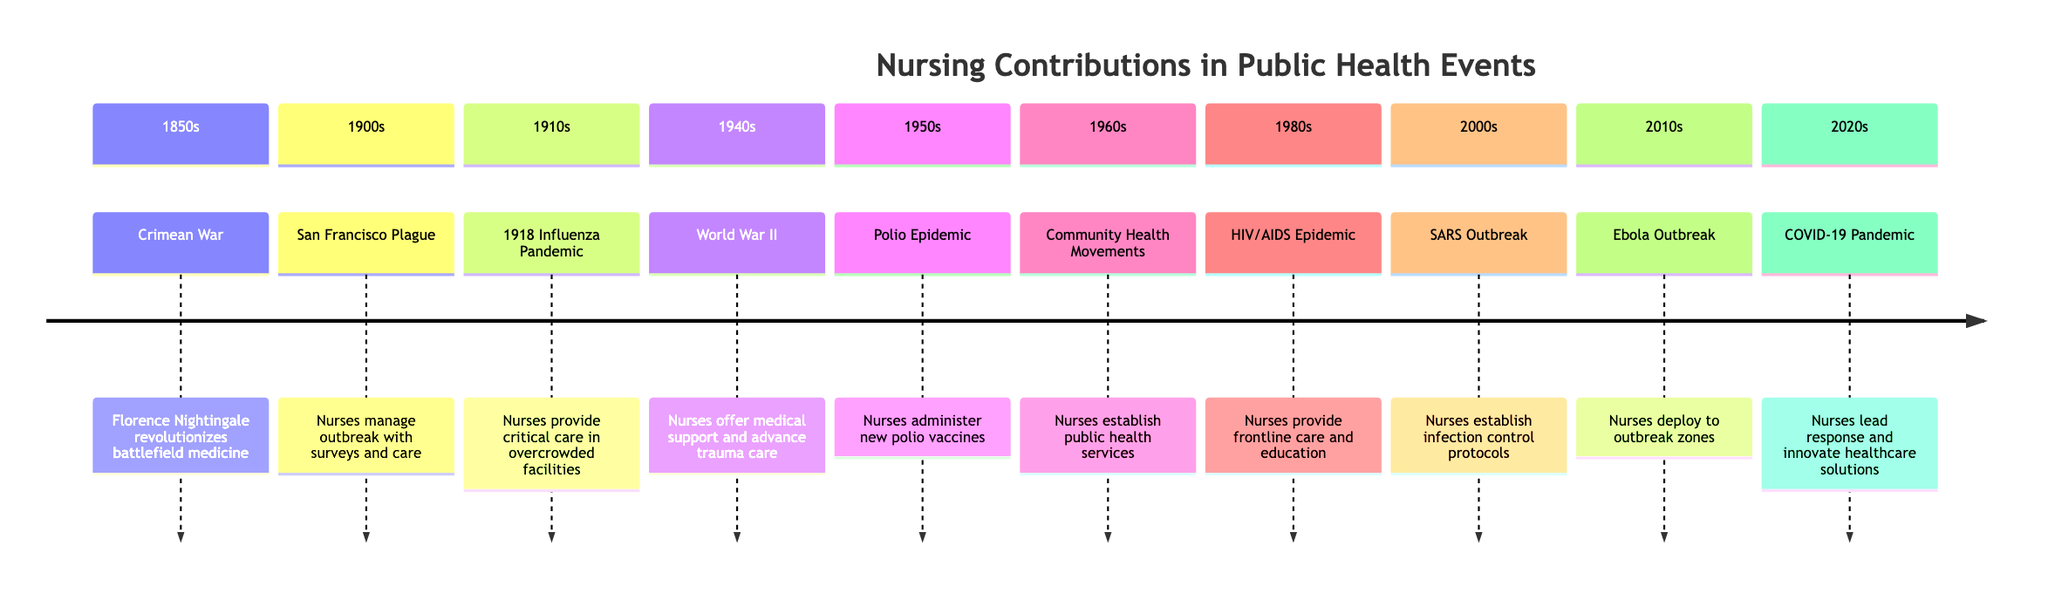What significant event occurred in the 1850s? The timeline indicates that the Crimean War was the significant event in the 1850s.
Answer: Crimean War How did nurses contribute during the 1900s event? According to the timeline, nurses managed the outbreak by conducting house-to-house surveys and providing patient care and isolation during the San Francisco Plague.
Answer: Conducting surveys and providing care What nursing contribution was made in the 1910s? The timeline notes that during the 1918 Influenza Pandemic, nurses provided critical care in overcrowded hospitals and temporary facilities.
Answer: Critical care in overcrowded hospitals How many decades are represented in the timeline? The timeline shows events from the 1850s to the 2020s, covering eight decades, which can be counted directly from the timeline sections.
Answer: Eight Which nursing contribution is linked to the 1980s? The timeline indicates that during the HIV/AIDS epidemic in the 1980s, nurses provided frontline care, support, and education.
Answer: Frontline care, support, and education What major public health challenge did nurses face in the 2000s? The timeline points out that during the SARS outbreak in the 2000s, nurses responded rapidly to emerging infectious diseases, indicating a significant challenge.
Answer: Emerging infectious diseases In which decade did nurses administer new polio vaccines? According to the timeline, nurses administered the new polio vaccines in the 1950s.
Answer: 1950s What was a common role of nurses throughout the timeline? Reviewing the contributions listed, it becomes clear that a common role was providing patient care or support during various health crises, consistently noted across multiple decades.
Answer: Providing patient care or support Which event occurred just before the COVID-19 pandemic? The timeline shows that the Ebola outbreak in the 2010s occurred just before the COVID-19 pandemic in the 2020s.
Answer: Ebola Outbreak 